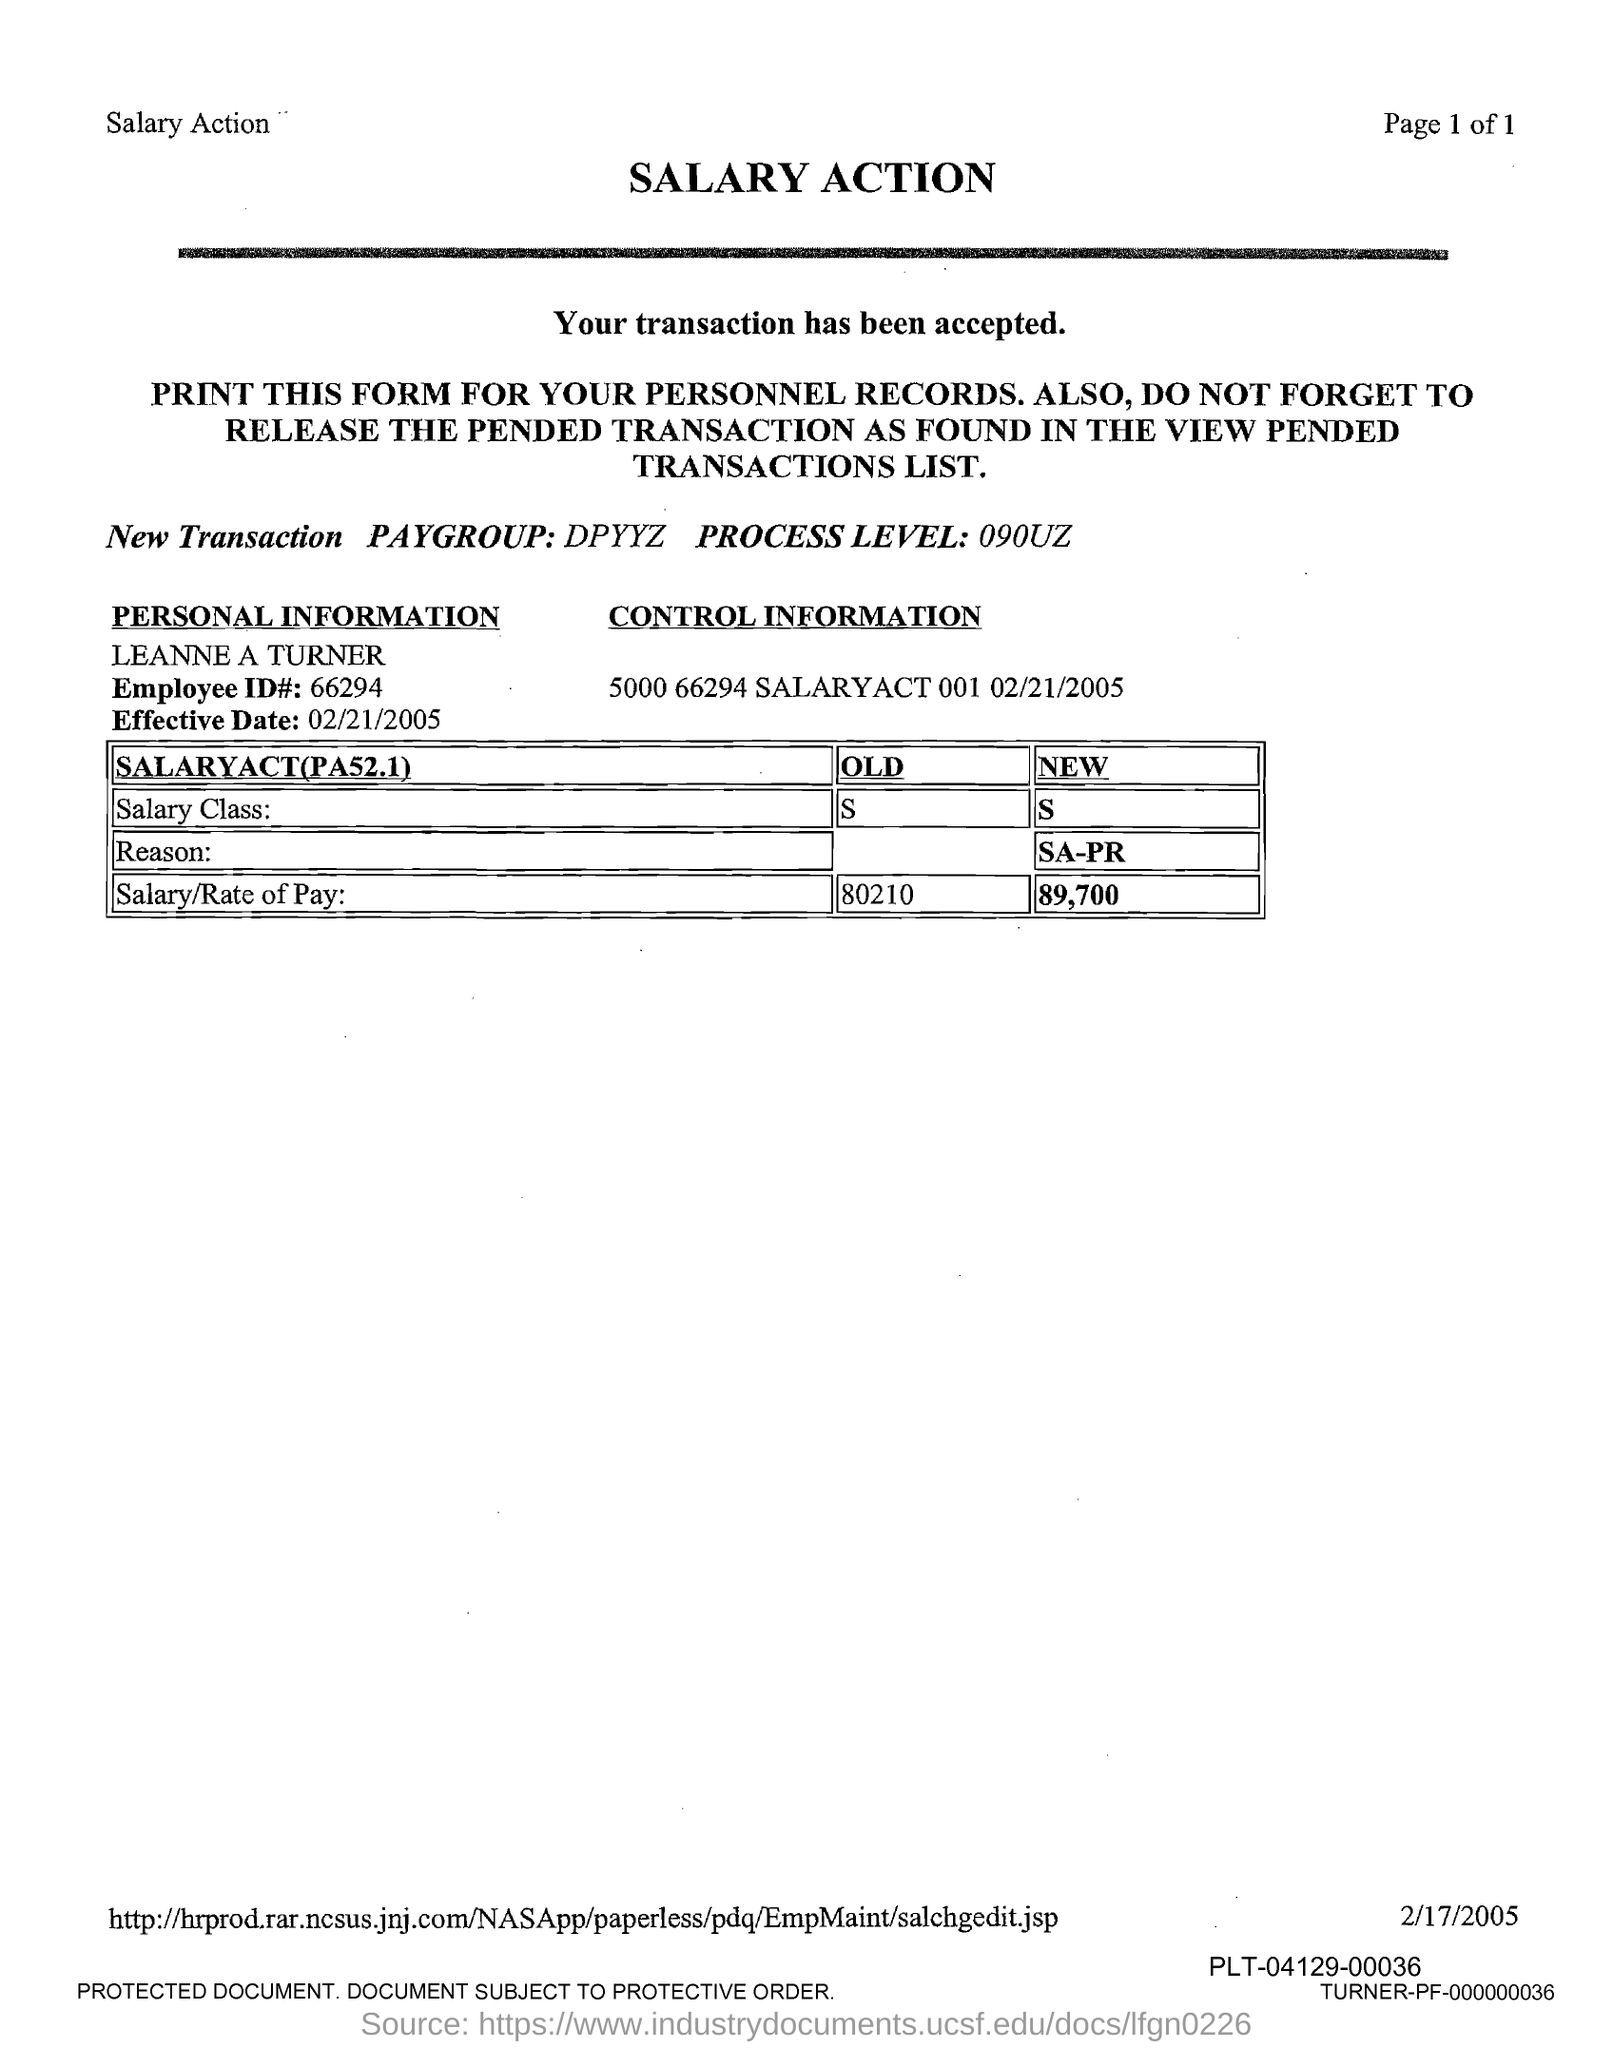Outline some significant characteristics in this image. The employee name provided in the form is "Leanne A Turner". The Employee ID number provided in the form is 66294. The new salary/rate of pay of Leanne A Turner is 89,700. The new salary class, as specified in the form, is [insert value here]. The effective date mentioned in the form is February 21, 2005. 